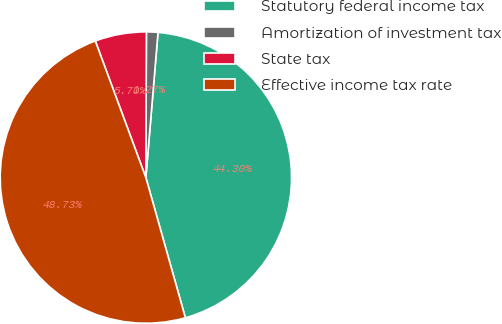Convert chart. <chart><loc_0><loc_0><loc_500><loc_500><pie_chart><fcel>Statutory federal income tax<fcel>Amortization of investment tax<fcel>State tax<fcel>Effective income tax rate<nl><fcel>44.3%<fcel>1.27%<fcel>5.7%<fcel>48.73%<nl></chart> 